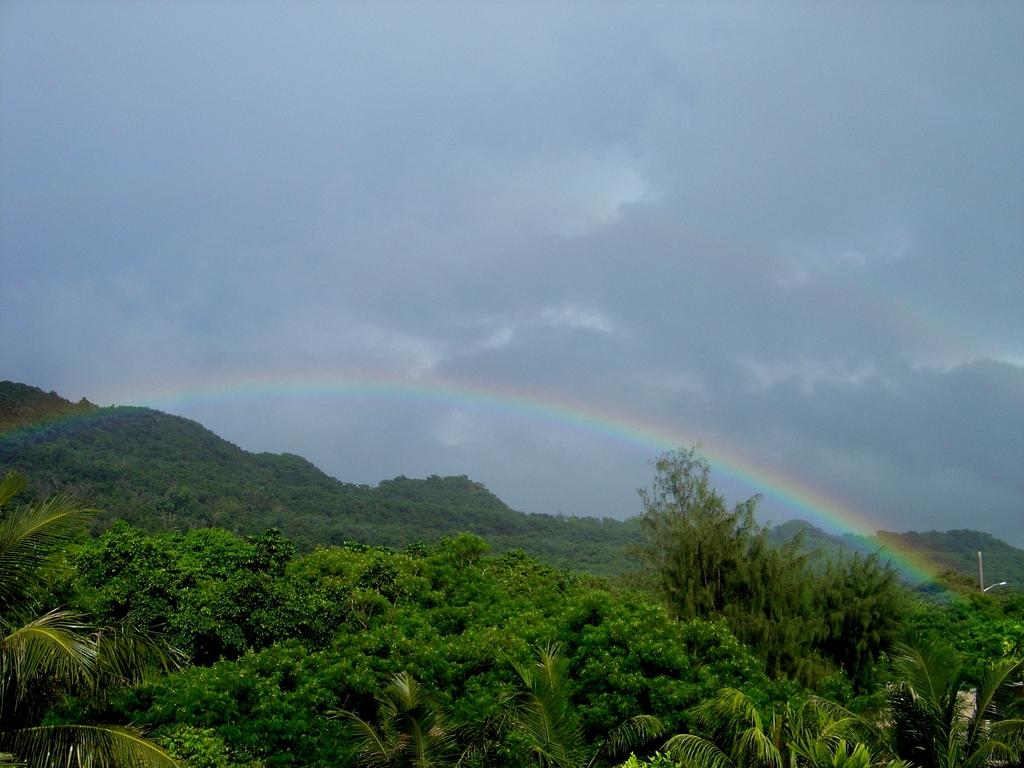What natural features are located at the bottom of the image? There are trees and a mountain at the bottom of the image. What man-made object can be seen on the right side of the image? There is a street light on the right side of the image. What atmospheric phenomenon is visible in the image? A rainbow is visible in the image. What part of the natural environment is visible at the top of the image? The sky is visible at the top of the image. What type of weather condition can be inferred from the presence of clouds in the sky? The presence of clouds in the sky suggests that there might be some weather conditions, such as overcast or partly cloudy. How does the cable affect the sleep of the trees in the image? There is no cable present in the image, and therefore it cannot affect the sleep of the trees. What type of shame is depicted in the image? There is no shame depicted in the image; it features natural elements and a street light. 